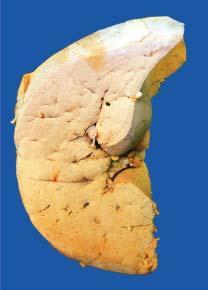does sectioned slice of the liver show pale yellow parenchyma with rounded borders?
Answer the question using a single word or phrase. Yes 